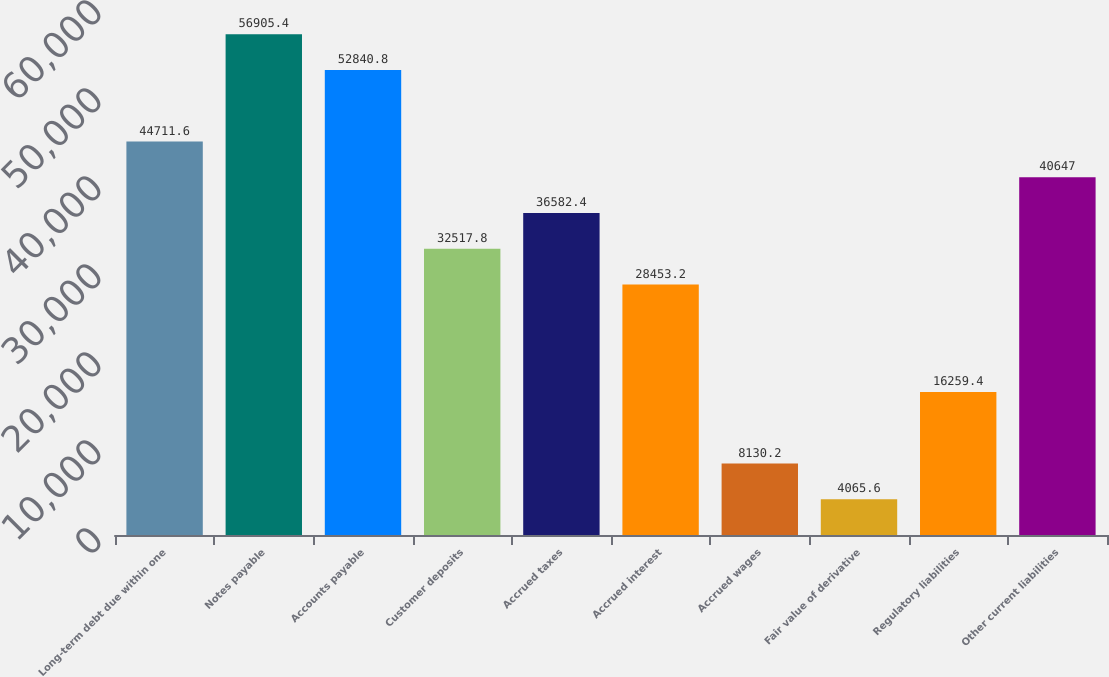Convert chart. <chart><loc_0><loc_0><loc_500><loc_500><bar_chart><fcel>Long-term debt due within one<fcel>Notes payable<fcel>Accounts payable<fcel>Customer deposits<fcel>Accrued taxes<fcel>Accrued interest<fcel>Accrued wages<fcel>Fair value of derivative<fcel>Regulatory liabilities<fcel>Other current liabilities<nl><fcel>44711.6<fcel>56905.4<fcel>52840.8<fcel>32517.8<fcel>36582.4<fcel>28453.2<fcel>8130.2<fcel>4065.6<fcel>16259.4<fcel>40647<nl></chart> 